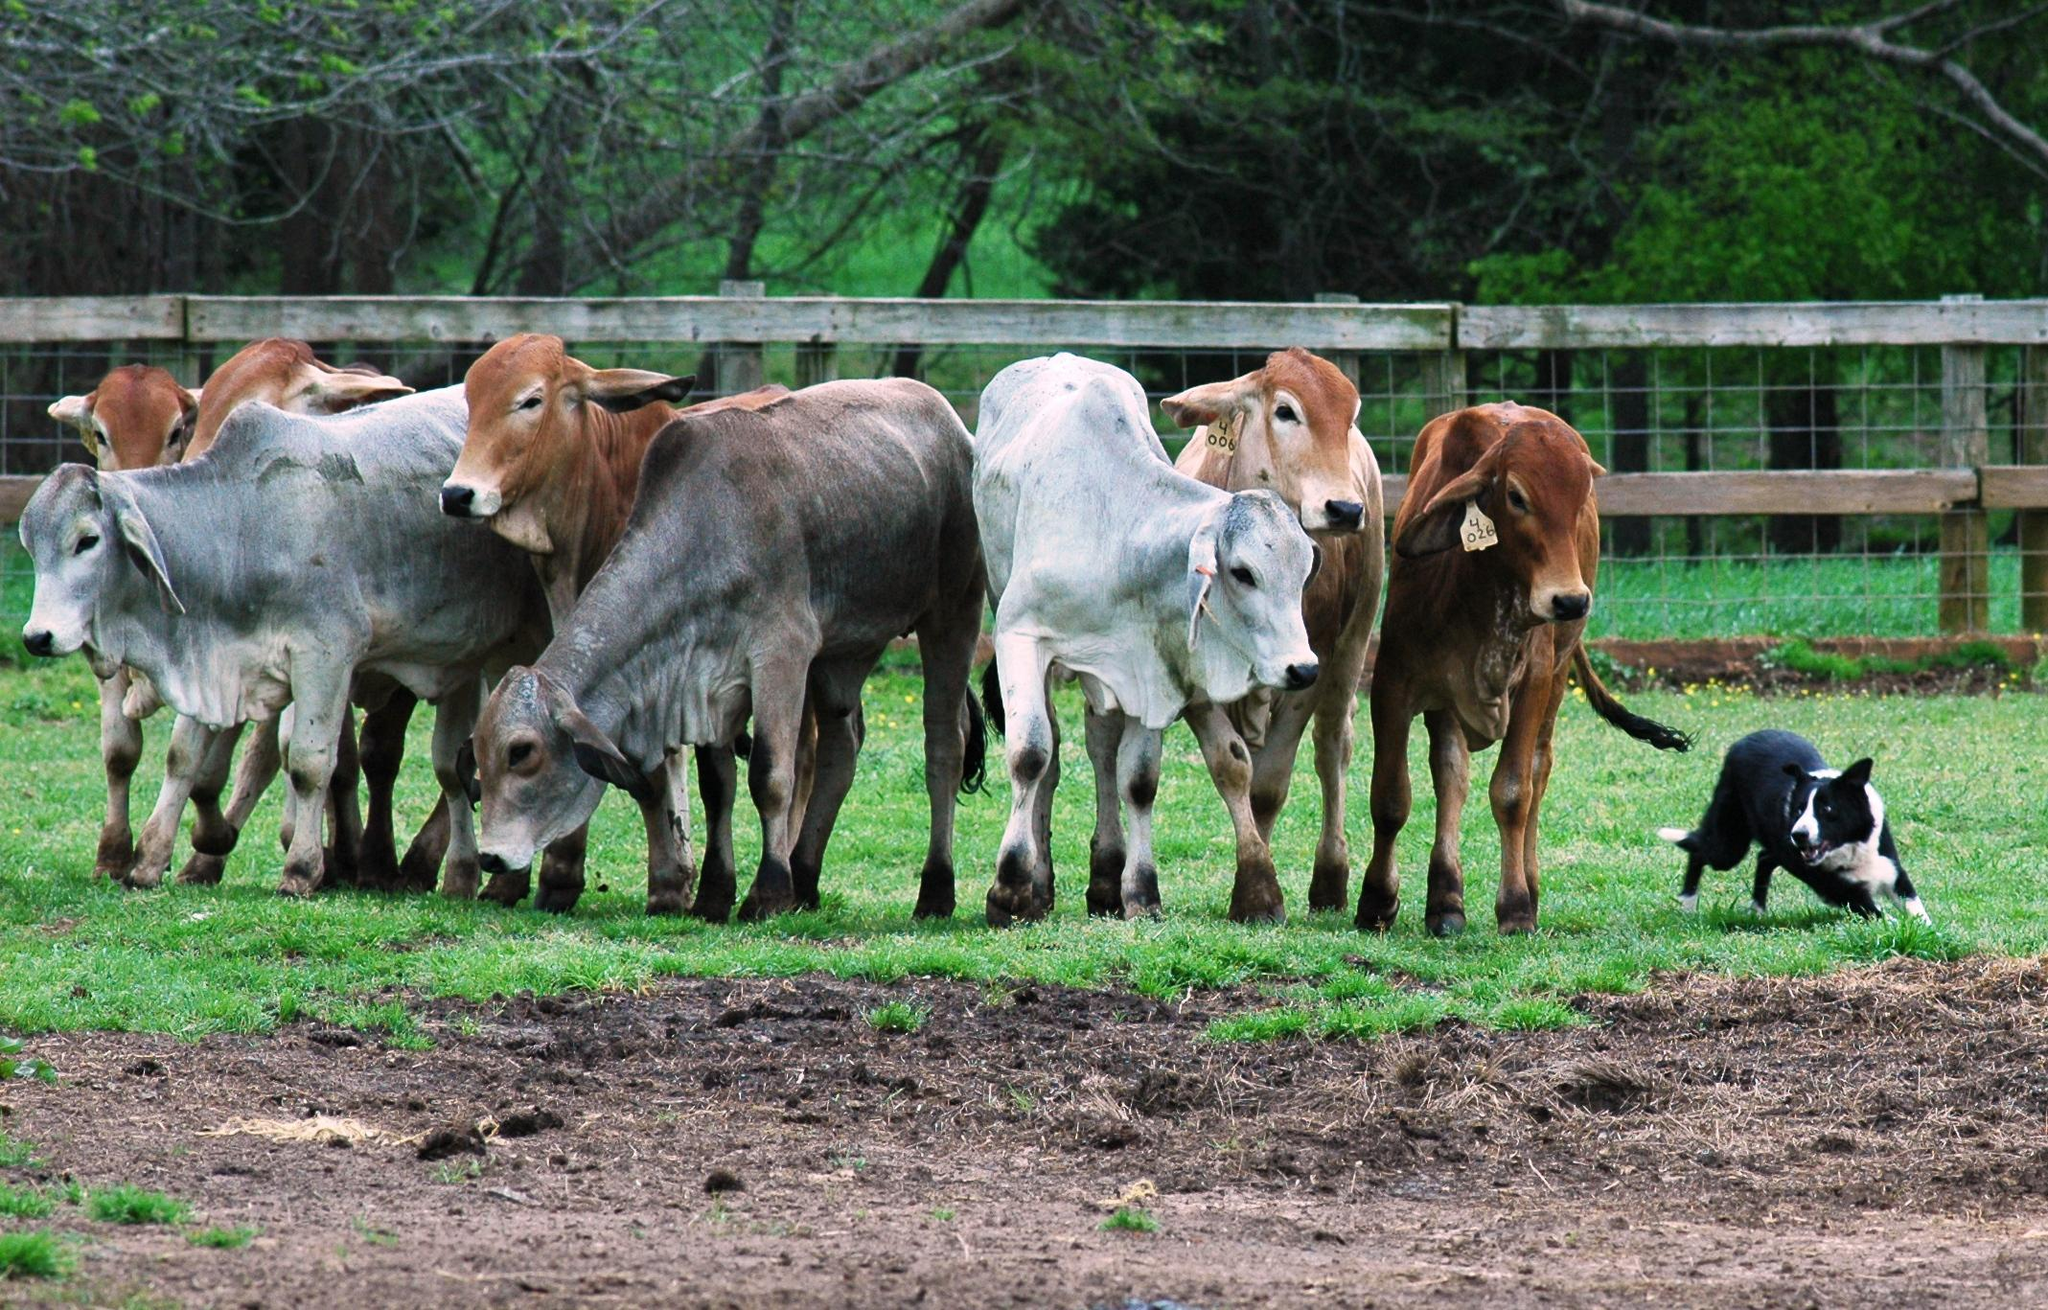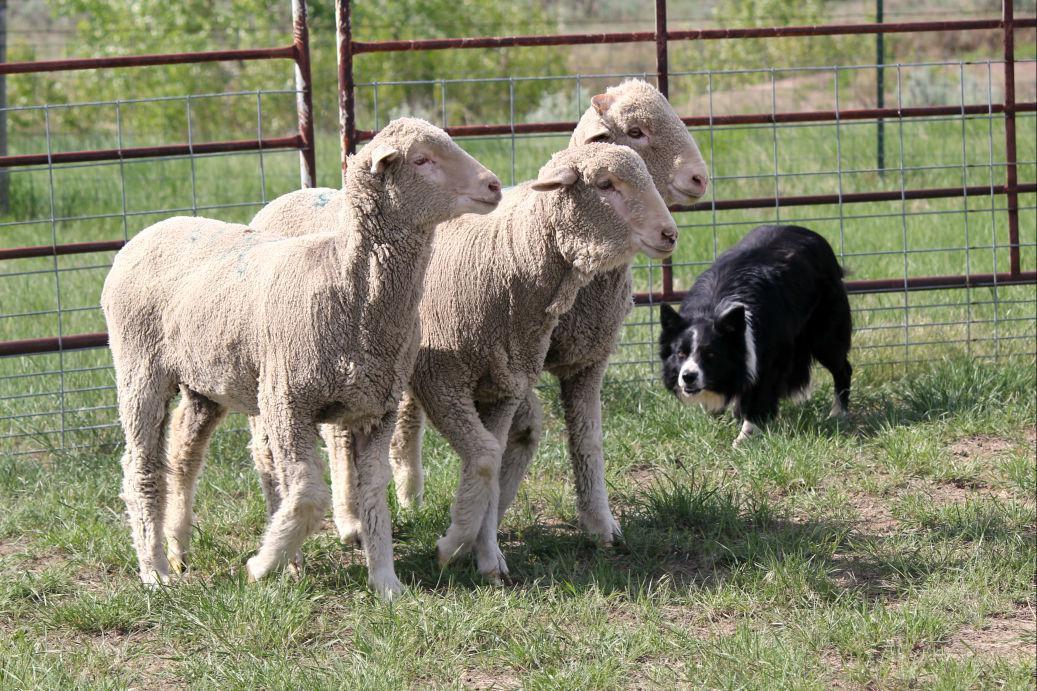The first image is the image on the left, the second image is the image on the right. Analyze the images presented: Is the assertion "The dog in the image on the left is rounding up cattle." valid? Answer yes or no. Yes. The first image is the image on the left, the second image is the image on the right. Assess this claim about the two images: "There are three sheeps and one dog in one of the images.". Correct or not? Answer yes or no. Yes. 